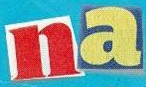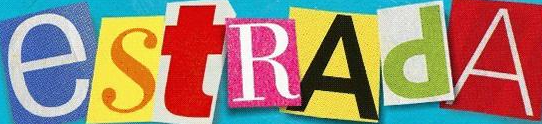Read the text content from these images in order, separated by a semicolon. na; estRAdA 